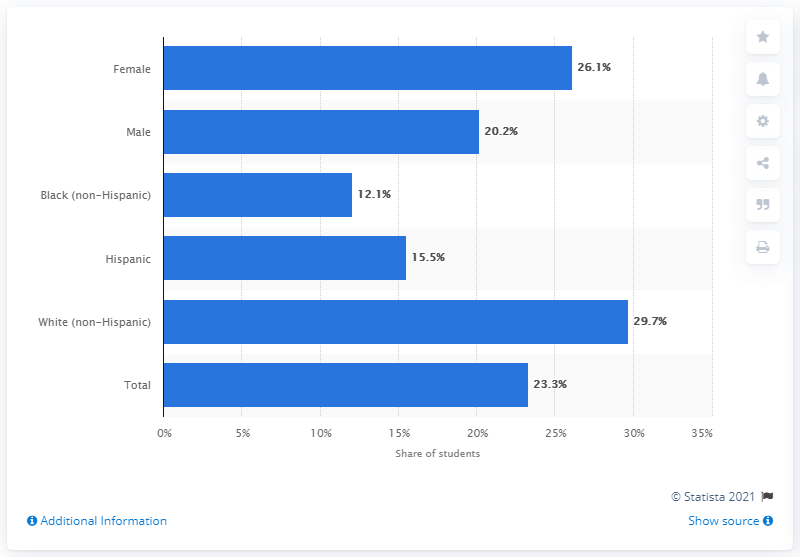List a handful of essential elements in this visual. According to a survey of female students, 26.1% reported using the birth control pill to prevent pregnancy during their most recent sexual intercourse. 